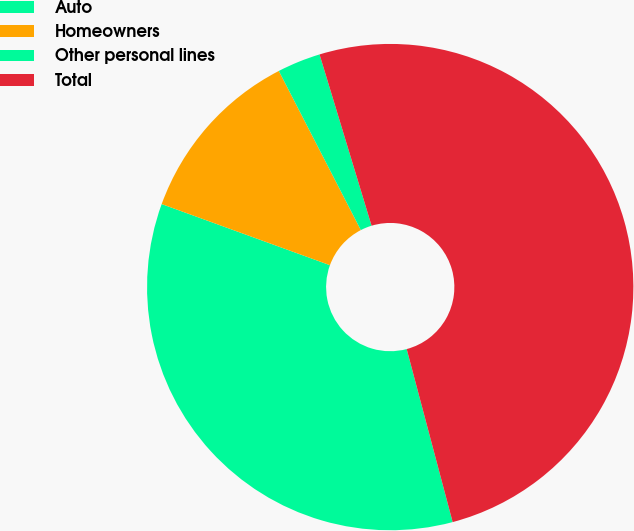Convert chart. <chart><loc_0><loc_0><loc_500><loc_500><pie_chart><fcel>Auto<fcel>Homeowners<fcel>Other personal lines<fcel>Total<nl><fcel>34.68%<fcel>11.88%<fcel>2.88%<fcel>50.56%<nl></chart> 